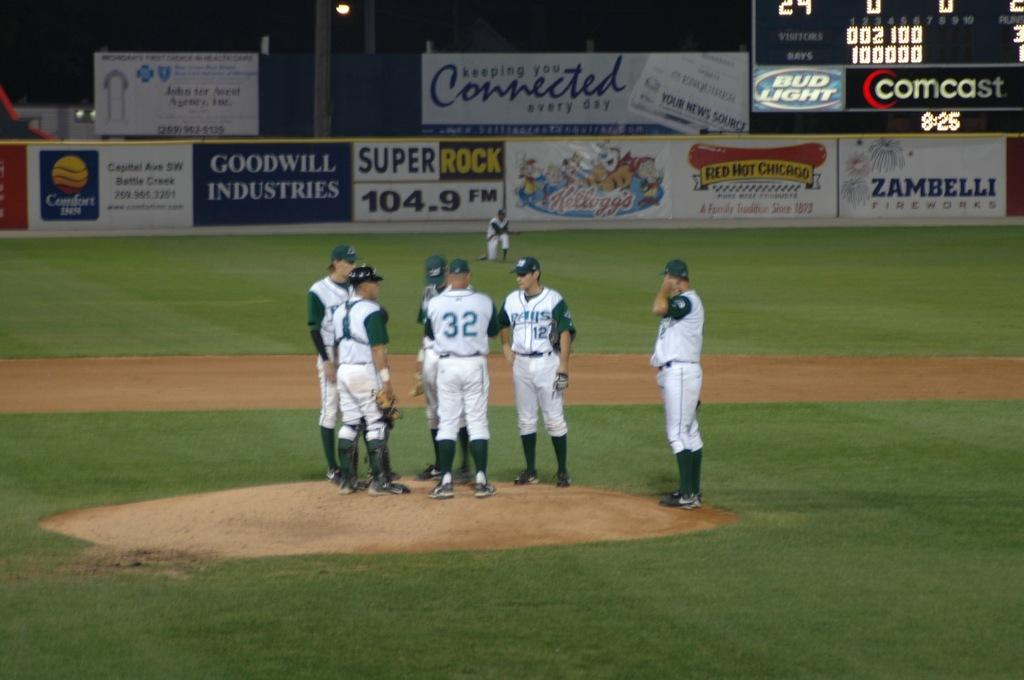Provide a one-sentence caption for the provided image. Baseball players converge on the pitcher's mound in front of the outfield fence, which bears an advertisement for Goodwill Industries. 